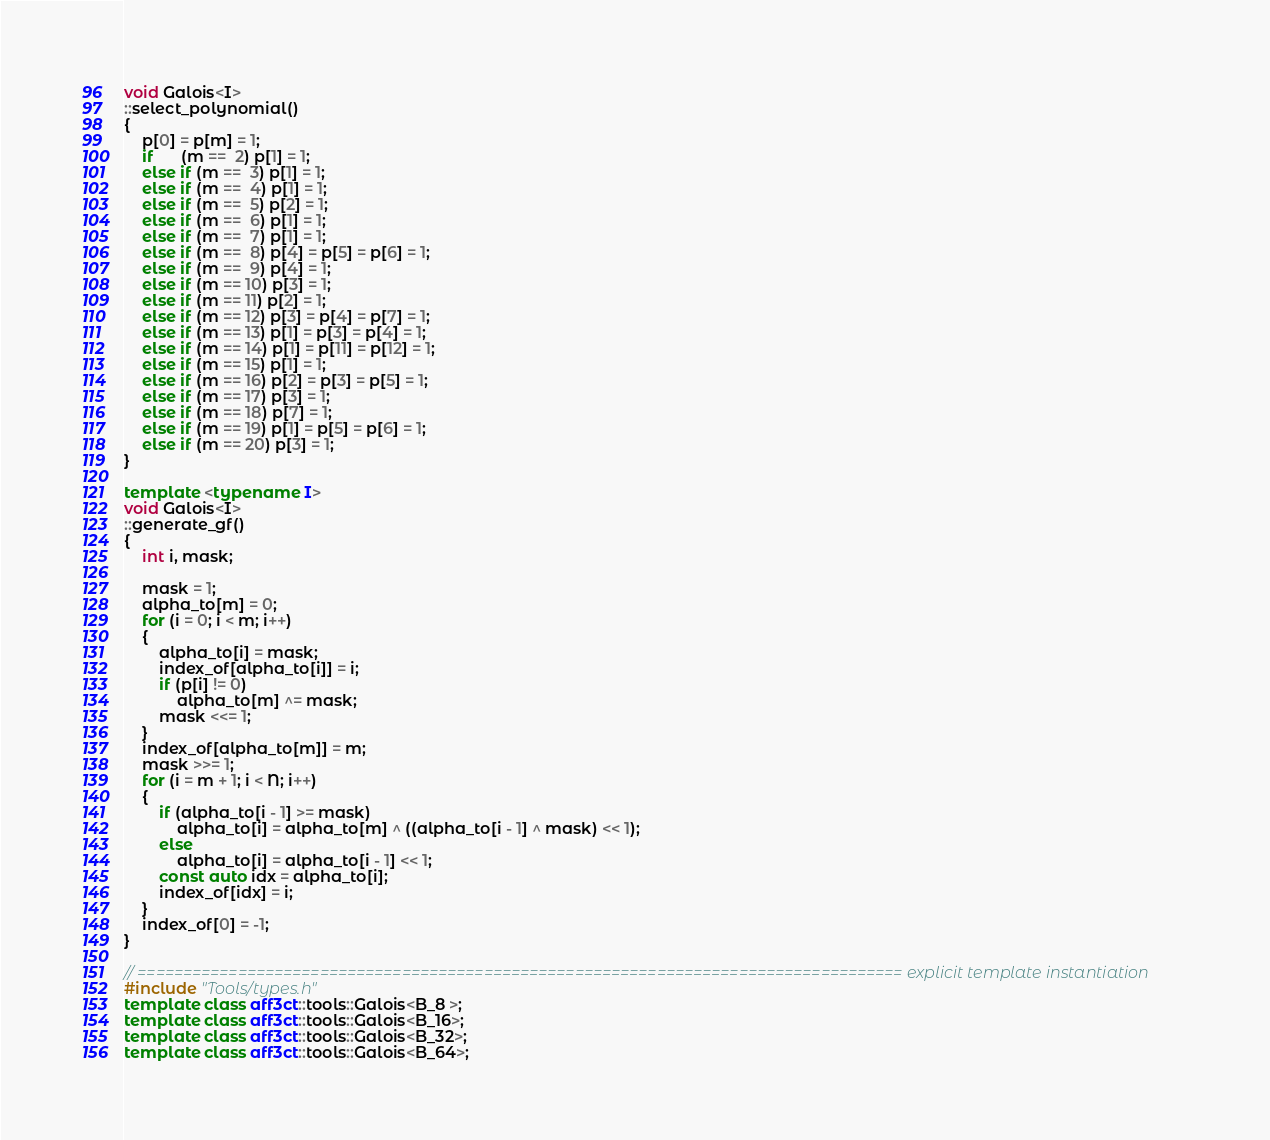Convert code to text. <code><loc_0><loc_0><loc_500><loc_500><_C++_>void Galois<I>
::select_polynomial()
{
	p[0] = p[m] = 1;
	if      (m ==  2) p[1] = 1;
	else if (m ==  3) p[1] = 1;
	else if (m ==  4) p[1] = 1;
	else if (m ==  5) p[2] = 1;
	else if (m ==  6) p[1] = 1;
	else if (m ==  7) p[1] = 1;
	else if (m ==  8) p[4] = p[5] = p[6] = 1;
	else if (m ==  9) p[4] = 1;
	else if (m == 10) p[3] = 1;
	else if (m == 11) p[2] = 1;
	else if (m == 12) p[3] = p[4] = p[7] = 1;
	else if (m == 13) p[1] = p[3] = p[4] = 1;
	else if (m == 14) p[1] = p[11] = p[12] = 1;
	else if (m == 15) p[1] = 1;
	else if (m == 16) p[2] = p[3] = p[5] = 1;
	else if (m == 17) p[3] = 1;
	else if (m == 18) p[7] = 1;
	else if (m == 19) p[1] = p[5] = p[6] = 1;
	else if (m == 20) p[3] = 1;
}

template <typename I>
void Galois<I>
::generate_gf()
{
	int i, mask;

	mask = 1;
	alpha_to[m] = 0;
	for (i = 0; i < m; i++)
	{
		alpha_to[i] = mask;
		index_of[alpha_to[i]] = i;
		if (p[i] != 0)
			alpha_to[m] ^= mask;
		mask <<= 1;
	}
	index_of[alpha_to[m]] = m;
	mask >>= 1;
	for (i = m + 1; i < N; i++)
	{
		if (alpha_to[i - 1] >= mask)
			alpha_to[i] = alpha_to[m] ^ ((alpha_to[i - 1] ^ mask) << 1);
		else
			alpha_to[i] = alpha_to[i - 1] << 1;
		const auto idx = alpha_to[i];
		index_of[idx] = i;
	}
	index_of[0] = -1;
}

// ==================================================================================== explicit template instantiation
#include "Tools/types.h"
template class aff3ct::tools::Galois<B_8 >;
template class aff3ct::tools::Galois<B_16>;
template class aff3ct::tools::Galois<B_32>;
template class aff3ct::tools::Galois<B_64>;</code> 